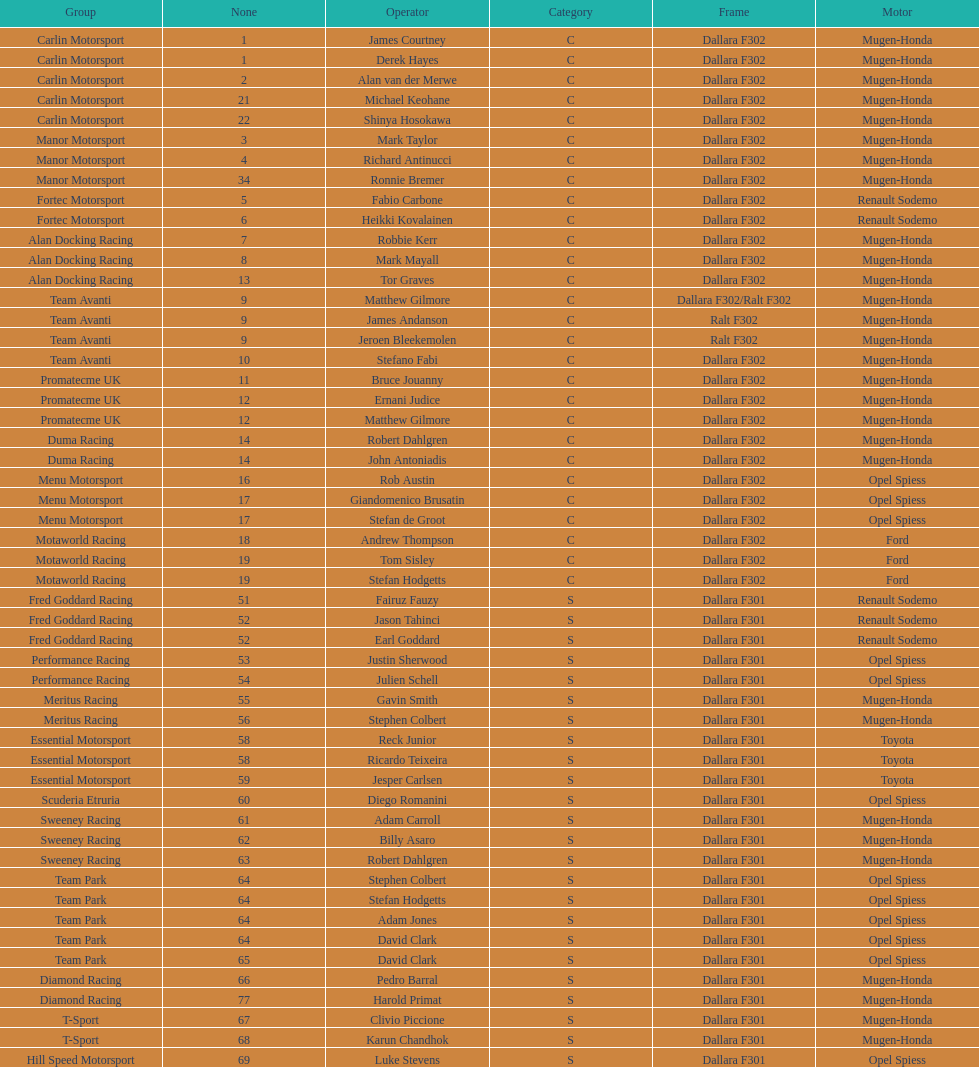How many class s (scholarship) teams are on the chart? 19. Parse the full table. {'header': ['Group', 'None', 'Operator', 'Category', 'Frame', 'Motor'], 'rows': [['Carlin Motorsport', '1', 'James Courtney', 'C', 'Dallara F302', 'Mugen-Honda'], ['Carlin Motorsport', '1', 'Derek Hayes', 'C', 'Dallara F302', 'Mugen-Honda'], ['Carlin Motorsport', '2', 'Alan van der Merwe', 'C', 'Dallara F302', 'Mugen-Honda'], ['Carlin Motorsport', '21', 'Michael Keohane', 'C', 'Dallara F302', 'Mugen-Honda'], ['Carlin Motorsport', '22', 'Shinya Hosokawa', 'C', 'Dallara F302', 'Mugen-Honda'], ['Manor Motorsport', '3', 'Mark Taylor', 'C', 'Dallara F302', 'Mugen-Honda'], ['Manor Motorsport', '4', 'Richard Antinucci', 'C', 'Dallara F302', 'Mugen-Honda'], ['Manor Motorsport', '34', 'Ronnie Bremer', 'C', 'Dallara F302', 'Mugen-Honda'], ['Fortec Motorsport', '5', 'Fabio Carbone', 'C', 'Dallara F302', 'Renault Sodemo'], ['Fortec Motorsport', '6', 'Heikki Kovalainen', 'C', 'Dallara F302', 'Renault Sodemo'], ['Alan Docking Racing', '7', 'Robbie Kerr', 'C', 'Dallara F302', 'Mugen-Honda'], ['Alan Docking Racing', '8', 'Mark Mayall', 'C', 'Dallara F302', 'Mugen-Honda'], ['Alan Docking Racing', '13', 'Tor Graves', 'C', 'Dallara F302', 'Mugen-Honda'], ['Team Avanti', '9', 'Matthew Gilmore', 'C', 'Dallara F302/Ralt F302', 'Mugen-Honda'], ['Team Avanti', '9', 'James Andanson', 'C', 'Ralt F302', 'Mugen-Honda'], ['Team Avanti', '9', 'Jeroen Bleekemolen', 'C', 'Ralt F302', 'Mugen-Honda'], ['Team Avanti', '10', 'Stefano Fabi', 'C', 'Dallara F302', 'Mugen-Honda'], ['Promatecme UK', '11', 'Bruce Jouanny', 'C', 'Dallara F302', 'Mugen-Honda'], ['Promatecme UK', '12', 'Ernani Judice', 'C', 'Dallara F302', 'Mugen-Honda'], ['Promatecme UK', '12', 'Matthew Gilmore', 'C', 'Dallara F302', 'Mugen-Honda'], ['Duma Racing', '14', 'Robert Dahlgren', 'C', 'Dallara F302', 'Mugen-Honda'], ['Duma Racing', '14', 'John Antoniadis', 'C', 'Dallara F302', 'Mugen-Honda'], ['Menu Motorsport', '16', 'Rob Austin', 'C', 'Dallara F302', 'Opel Spiess'], ['Menu Motorsport', '17', 'Giandomenico Brusatin', 'C', 'Dallara F302', 'Opel Spiess'], ['Menu Motorsport', '17', 'Stefan de Groot', 'C', 'Dallara F302', 'Opel Spiess'], ['Motaworld Racing', '18', 'Andrew Thompson', 'C', 'Dallara F302', 'Ford'], ['Motaworld Racing', '19', 'Tom Sisley', 'C', 'Dallara F302', 'Ford'], ['Motaworld Racing', '19', 'Stefan Hodgetts', 'C', 'Dallara F302', 'Ford'], ['Fred Goddard Racing', '51', 'Fairuz Fauzy', 'S', 'Dallara F301', 'Renault Sodemo'], ['Fred Goddard Racing', '52', 'Jason Tahinci', 'S', 'Dallara F301', 'Renault Sodemo'], ['Fred Goddard Racing', '52', 'Earl Goddard', 'S', 'Dallara F301', 'Renault Sodemo'], ['Performance Racing', '53', 'Justin Sherwood', 'S', 'Dallara F301', 'Opel Spiess'], ['Performance Racing', '54', 'Julien Schell', 'S', 'Dallara F301', 'Opel Spiess'], ['Meritus Racing', '55', 'Gavin Smith', 'S', 'Dallara F301', 'Mugen-Honda'], ['Meritus Racing', '56', 'Stephen Colbert', 'S', 'Dallara F301', 'Mugen-Honda'], ['Essential Motorsport', '58', 'Reck Junior', 'S', 'Dallara F301', 'Toyota'], ['Essential Motorsport', '58', 'Ricardo Teixeira', 'S', 'Dallara F301', 'Toyota'], ['Essential Motorsport', '59', 'Jesper Carlsen', 'S', 'Dallara F301', 'Toyota'], ['Scuderia Etruria', '60', 'Diego Romanini', 'S', 'Dallara F301', 'Opel Spiess'], ['Sweeney Racing', '61', 'Adam Carroll', 'S', 'Dallara F301', 'Mugen-Honda'], ['Sweeney Racing', '62', 'Billy Asaro', 'S', 'Dallara F301', 'Mugen-Honda'], ['Sweeney Racing', '63', 'Robert Dahlgren', 'S', 'Dallara F301', 'Mugen-Honda'], ['Team Park', '64', 'Stephen Colbert', 'S', 'Dallara F301', 'Opel Spiess'], ['Team Park', '64', 'Stefan Hodgetts', 'S', 'Dallara F301', 'Opel Spiess'], ['Team Park', '64', 'Adam Jones', 'S', 'Dallara F301', 'Opel Spiess'], ['Team Park', '64', 'David Clark', 'S', 'Dallara F301', 'Opel Spiess'], ['Team Park', '65', 'David Clark', 'S', 'Dallara F301', 'Opel Spiess'], ['Diamond Racing', '66', 'Pedro Barral', 'S', 'Dallara F301', 'Mugen-Honda'], ['Diamond Racing', '77', 'Harold Primat', 'S', 'Dallara F301', 'Mugen-Honda'], ['T-Sport', '67', 'Clivio Piccione', 'S', 'Dallara F301', 'Mugen-Honda'], ['T-Sport', '68', 'Karun Chandhok', 'S', 'Dallara F301', 'Mugen-Honda'], ['Hill Speed Motorsport', '69', 'Luke Stevens', 'S', 'Dallara F301', 'Opel Spiess']]} 